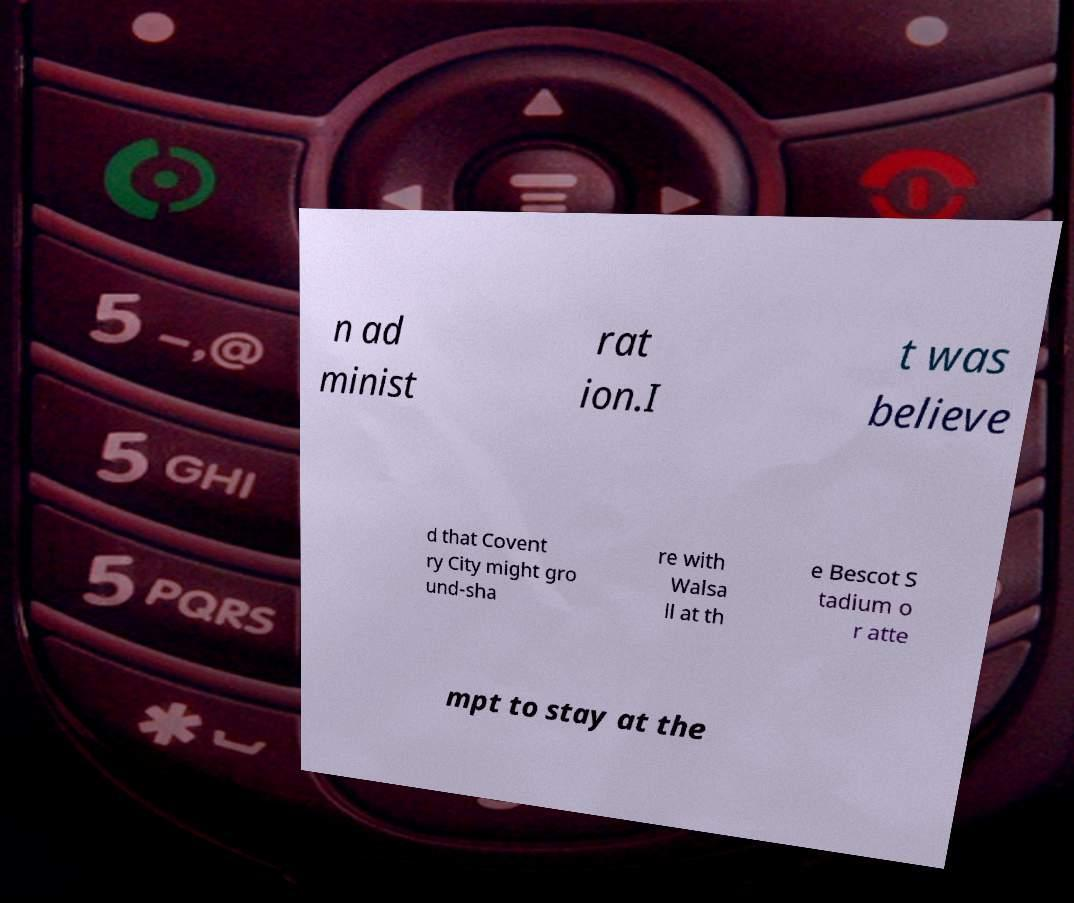Please read and relay the text visible in this image. What does it say? n ad minist rat ion.I t was believe d that Covent ry City might gro und-sha re with Walsa ll at th e Bescot S tadium o r atte mpt to stay at the 